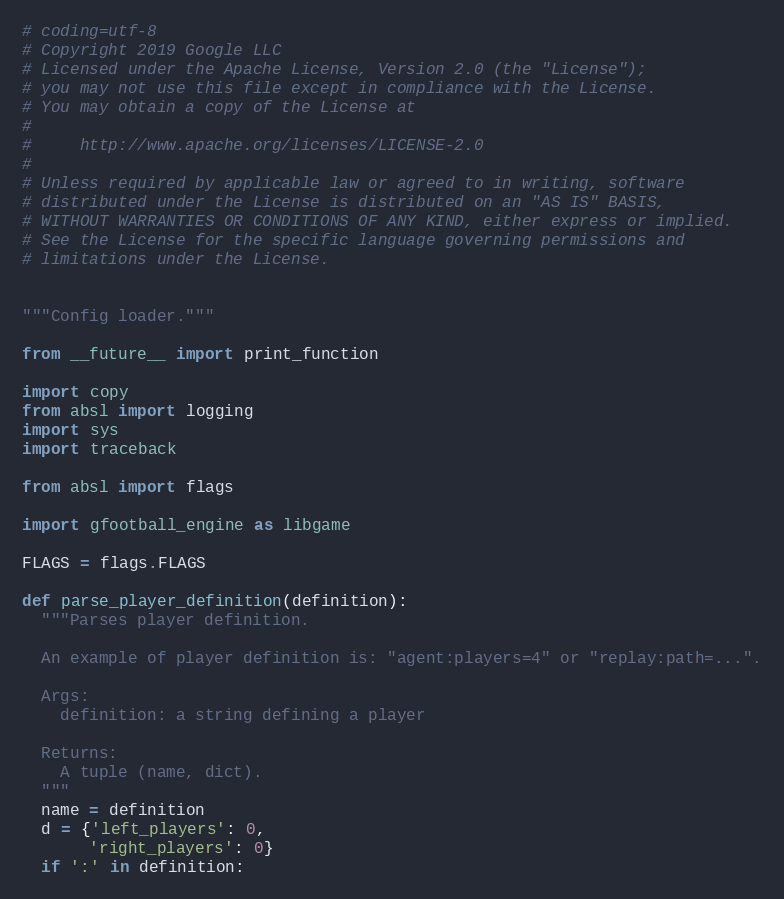<code> <loc_0><loc_0><loc_500><loc_500><_Python_># coding=utf-8
# Copyright 2019 Google LLC
# Licensed under the Apache License, Version 2.0 (the "License");
# you may not use this file except in compliance with the License.
# You may obtain a copy of the License at
#
#     http://www.apache.org/licenses/LICENSE-2.0
#
# Unless required by applicable law or agreed to in writing, software
# distributed under the License is distributed on an "AS IS" BASIS,
# WITHOUT WARRANTIES OR CONDITIONS OF ANY KIND, either express or implied.
# See the License for the specific language governing permissions and
# limitations under the License.


"""Config loader."""

from __future__ import print_function

import copy
from absl import logging
import sys
import traceback

from absl import flags

import gfootball_engine as libgame

FLAGS = flags.FLAGS

def parse_player_definition(definition):
  """Parses player definition.

  An example of player definition is: "agent:players=4" or "replay:path=...".

  Args:
    definition: a string defining a player

  Returns:
    A tuple (name, dict).
  """
  name = definition
  d = {'left_players': 0,
       'right_players': 0}
  if ':' in definition:</code> 